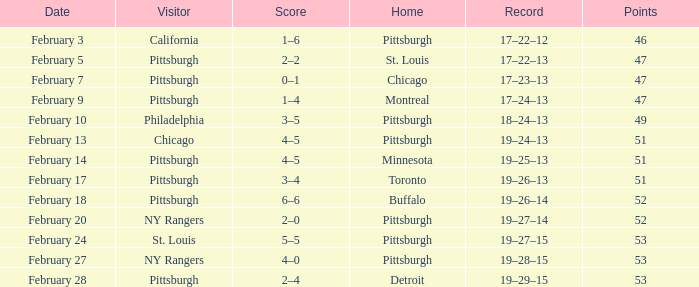What score does a visitor of ny rangers have, with a record of 19-28-15? 4–0. 